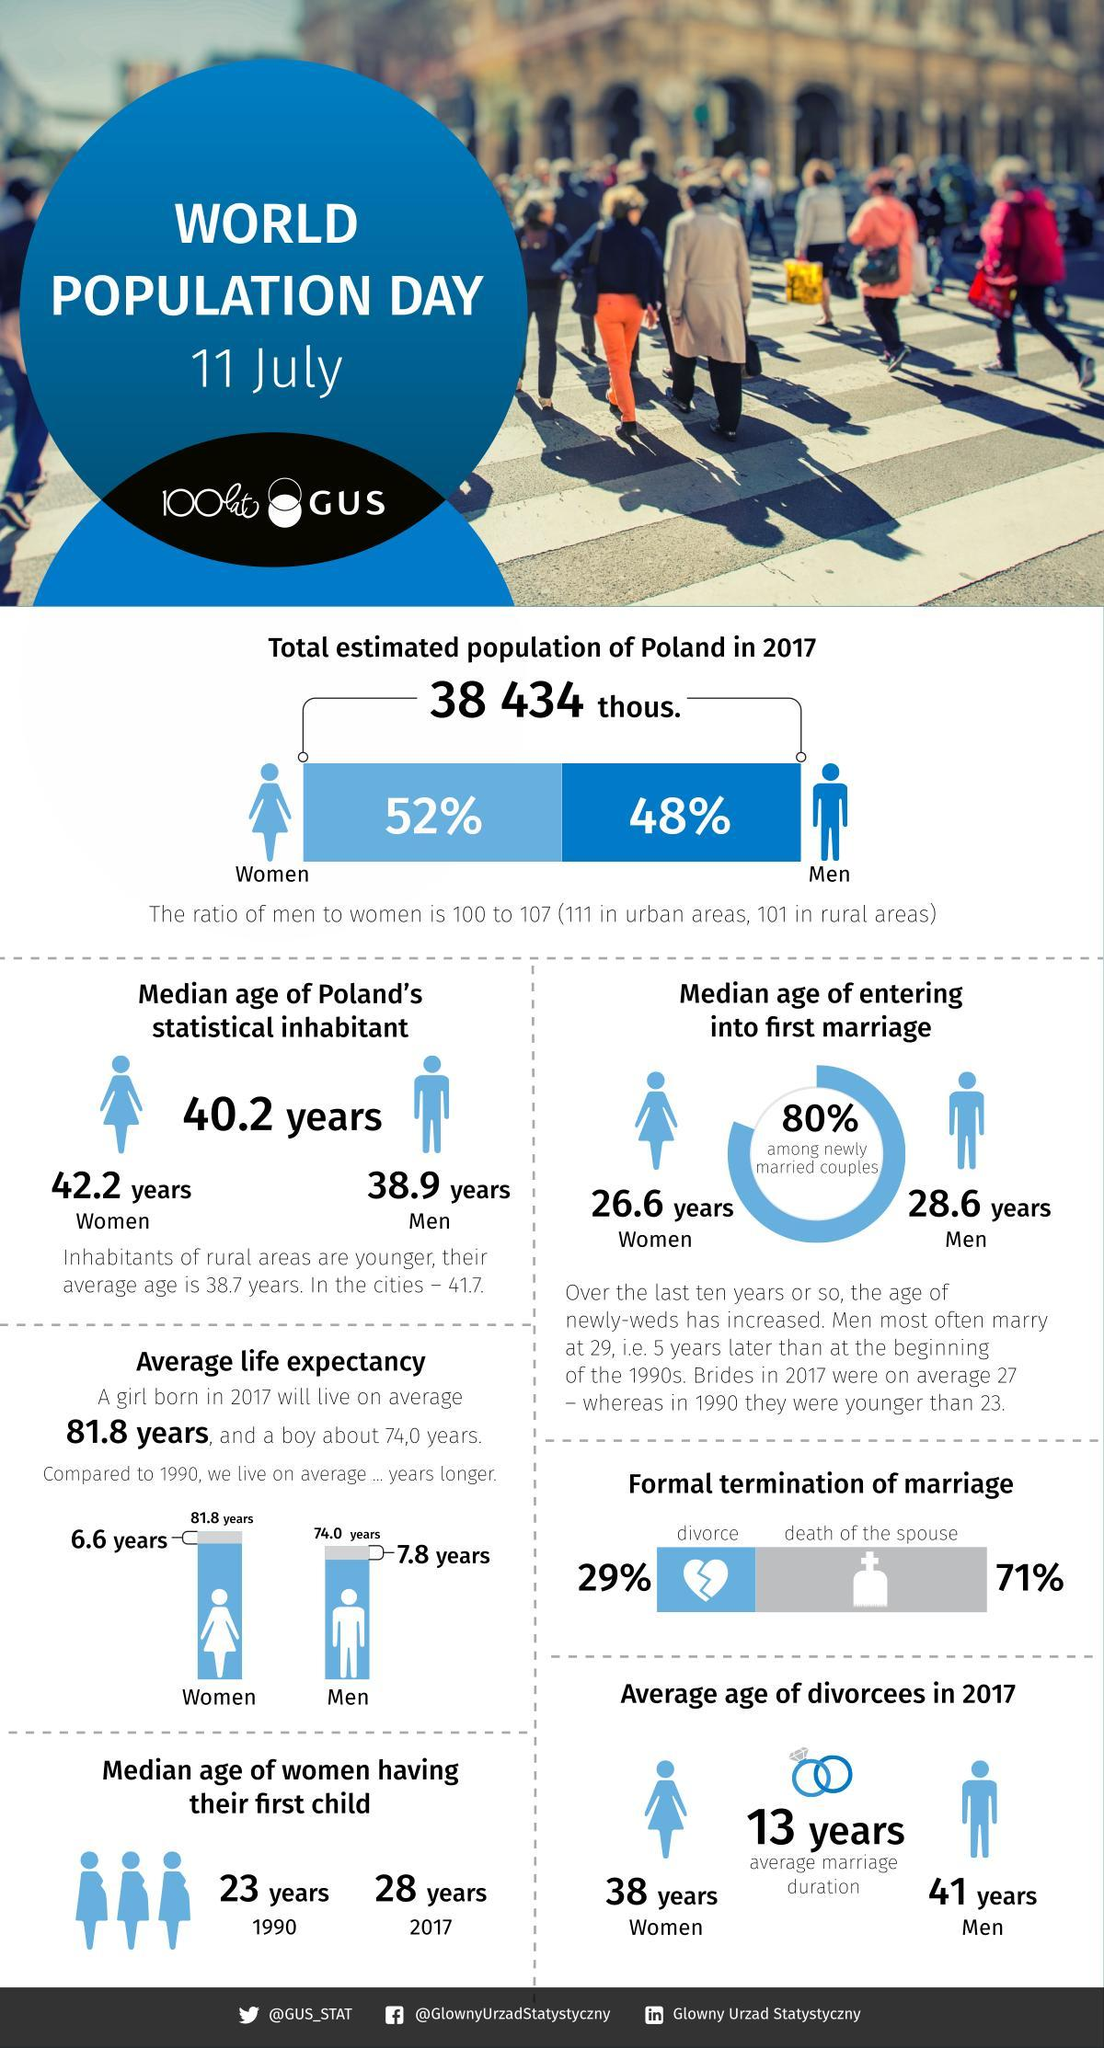What is the average life expectancy of a girl born in 1990?
Answer the question with a short phrase. 75.2 years What is the difference between the median age of women having their first child in 2017 and 1990? 5 years What is the average life expectancy of a boy born in 1990? 66.2 years 